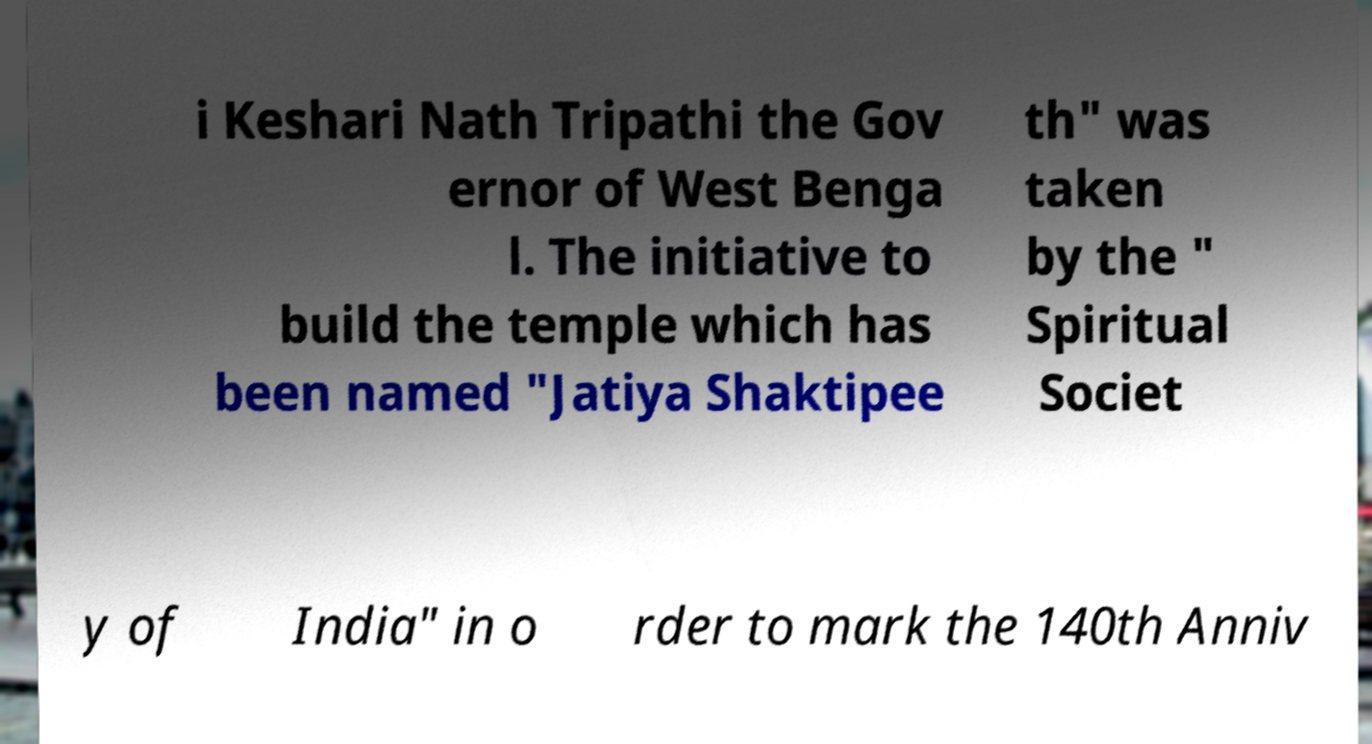Could you extract and type out the text from this image? i Keshari Nath Tripathi the Gov ernor of West Benga l. The initiative to build the temple which has been named "Jatiya Shaktipee th" was taken by the " Spiritual Societ y of India" in o rder to mark the 140th Anniv 